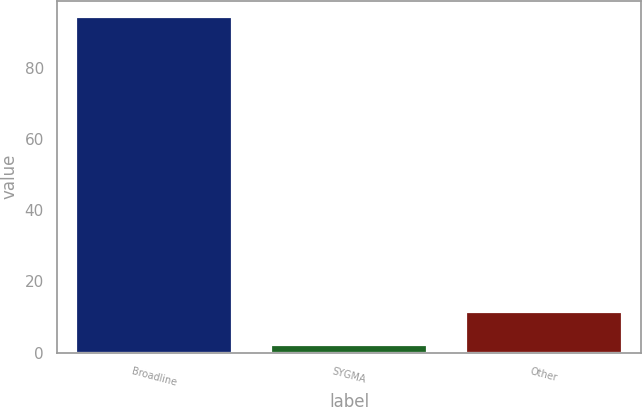Convert chart to OTSL. <chart><loc_0><loc_0><loc_500><loc_500><bar_chart><fcel>Broadline<fcel>SYGMA<fcel>Other<nl><fcel>94.1<fcel>2.1<fcel>11.3<nl></chart> 